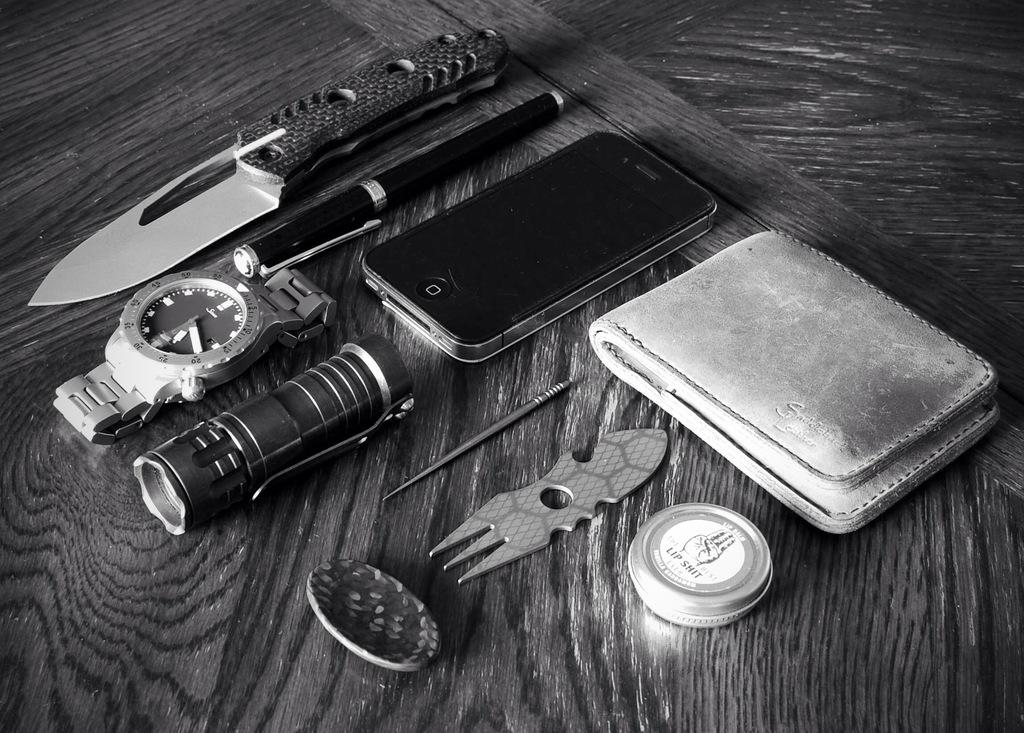<image>
Create a compact narrative representing the image presented. A collection of things including a tin of lip balm that says lip shit on it 